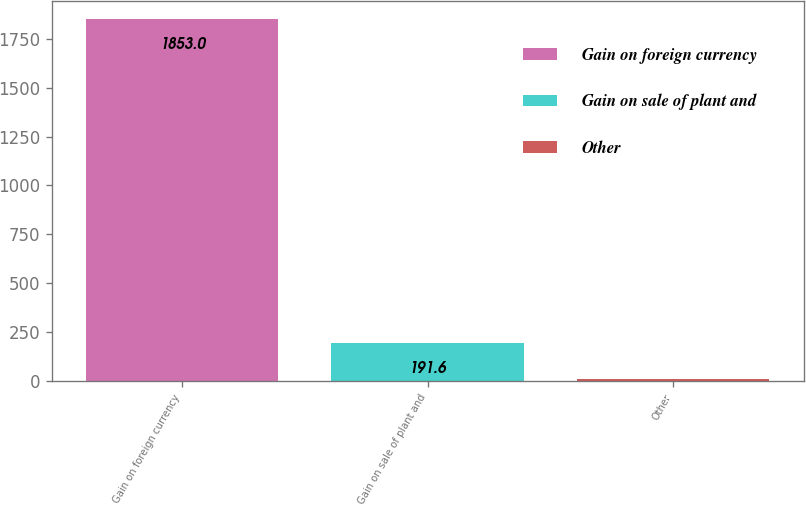<chart> <loc_0><loc_0><loc_500><loc_500><bar_chart><fcel>Gain on foreign currency<fcel>Gain on sale of plant and<fcel>Other<nl><fcel>1853<fcel>191.6<fcel>7<nl></chart> 